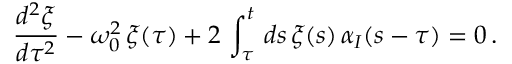Convert formula to latex. <formula><loc_0><loc_0><loc_500><loc_500>\frac { d ^ { 2 } \xi } { d \tau ^ { 2 } } - \omega _ { 0 } ^ { 2 } \, \xi ( \tau ) + 2 \, \int _ { \tau } ^ { t } \, d s \, \xi ( s ) \, \alpha _ { I } ( s - \tau ) = 0 \, .</formula> 